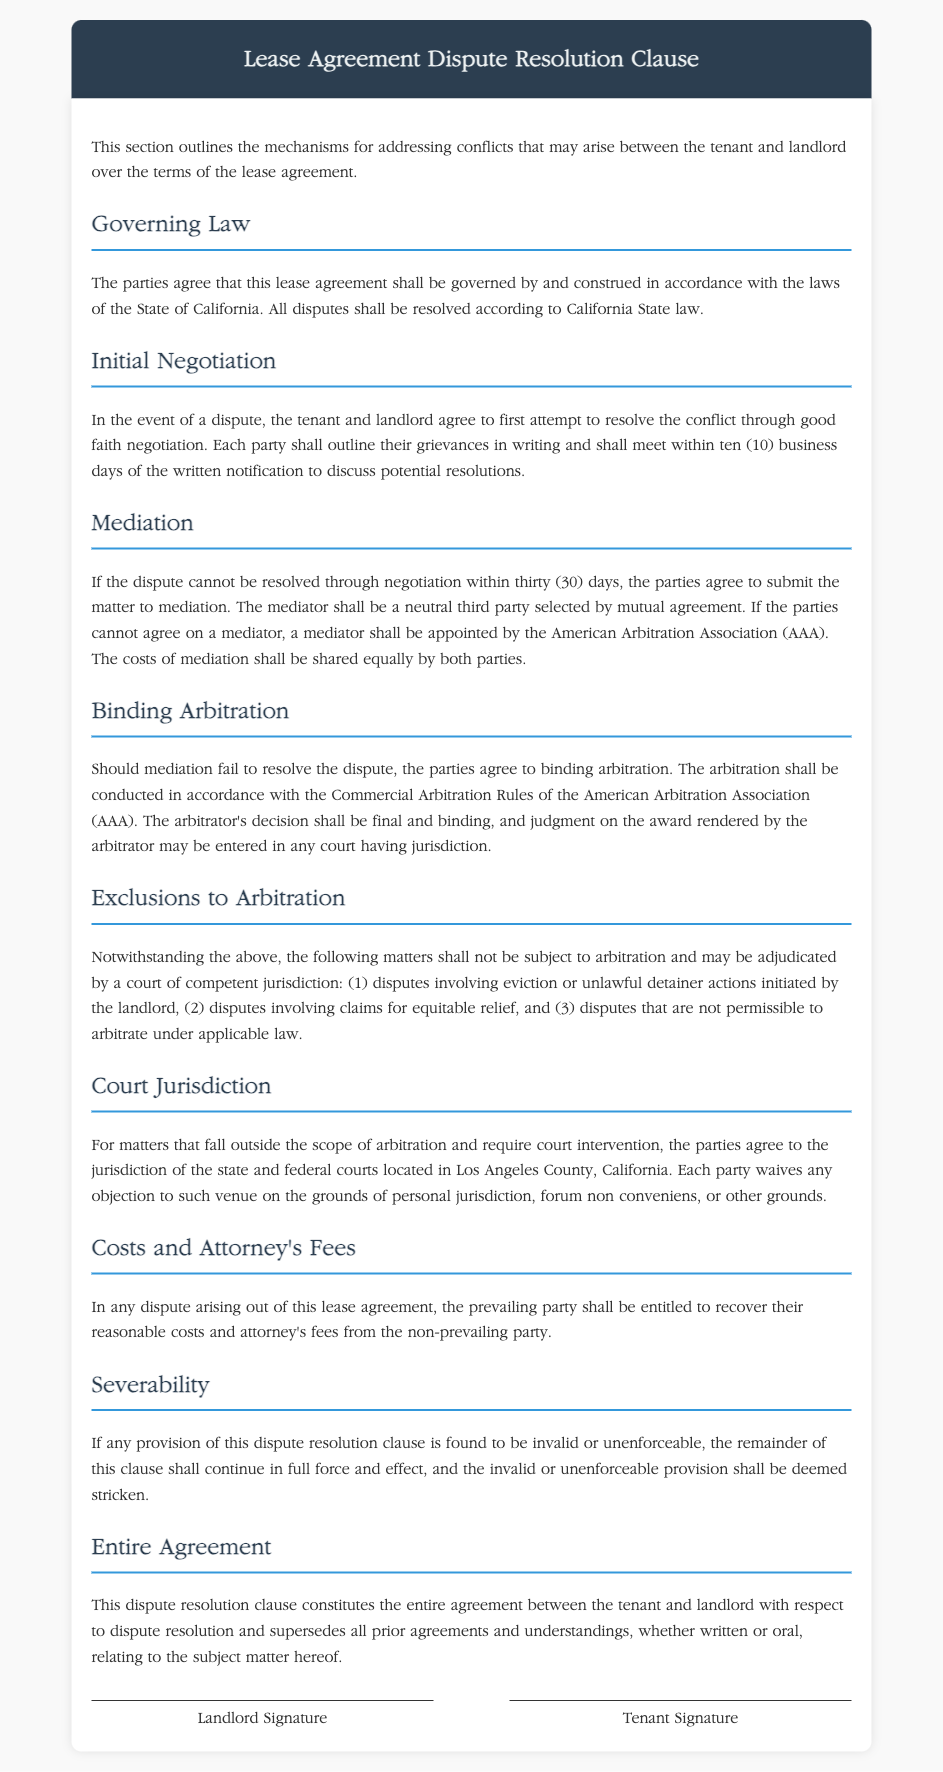What law governs this lease agreement? The lease agreement is governed by the laws of the State of California.
Answer: California What is the initial step for resolving disputes? The parties agree to first attempt to resolve the conflict through good faith negotiation.
Answer: Good faith negotiation How long do parties have to meet for negotiations? The parties are required to meet within ten business days of the written notification to discuss potential resolutions.
Answer: Ten business days What is the role of the American Arbitration Association in mediation? If parties cannot agree on a mediator, a mediator shall be appointed by the American Arbitration Association.
Answer: Appoint a mediator What happens if mediation fails? The parties agree to binding arbitration if mediation fails to resolve the dispute.
Answer: Binding arbitration Which disputes are excluded from arbitration? Disputes involving eviction or unlawful detainer actions initiated by the landlord are not subject to arbitration.
Answer: Eviction or unlawful detainer actions What is the prevailing party entitled to in a dispute? The prevailing party shall be entitled to recover their reasonable costs and attorney's fees from the non-prevailing party.
Answer: Recover costs and attorney's fees Where is the court jurisdiction for matters outside arbitration? The parties agree to the jurisdiction of the state and federal courts located in Los Angeles County, California.
Answer: Los Angeles County What occurs if a provision of the clause is invalid? The remainder of this clause shall continue in full force and effect, and the invalid provision shall be deemed stricken.
Answer: Continue in full force and effect 